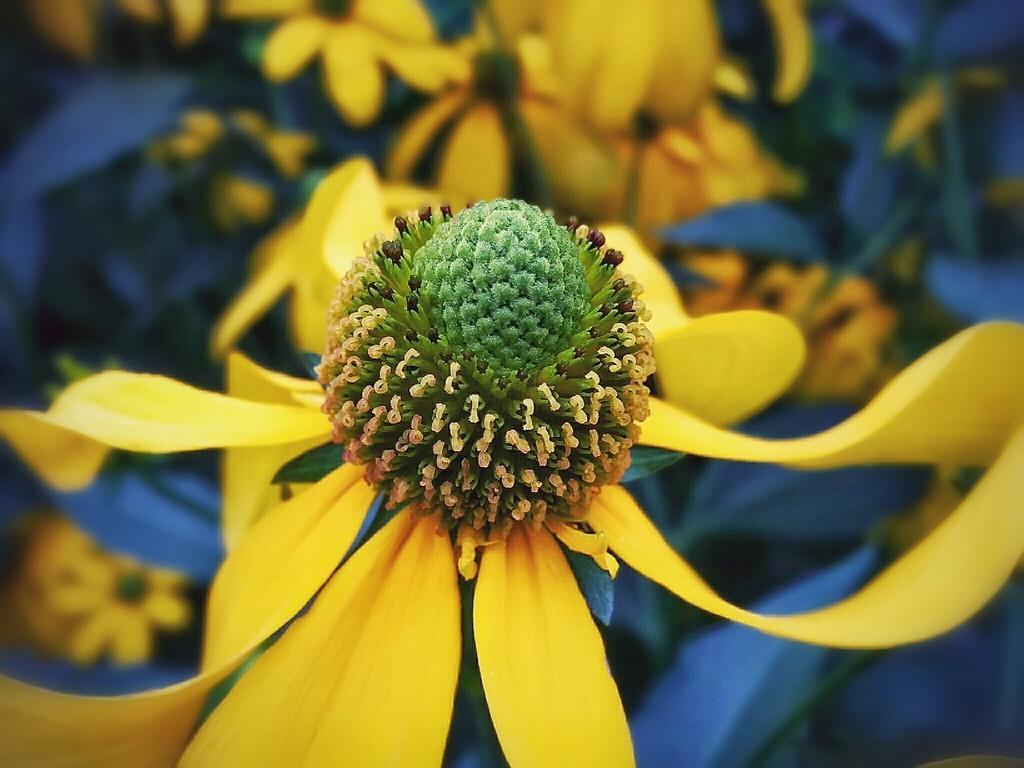Could you give a brief overview of what you see in this image? In this picture I can see there is a flower and it has few yellow petals and the backdrop is blurred and it looks like there are few more flowers in the backdrop. 